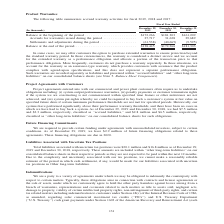According to Sunpower Corporation's financial document, In what situation is warranty accounted as an assurance-type warranty? Customers do not purchase a warranty separately. The document states: "to that performance obligation. More frequently, customers do not purchase a warranty separately. In those situations, we account for the warranty as ..." Also, What does an assurance-type warranty provide? Provides customers with assurance that the product complies with agreed-upon specifications. The document states: "the warranty as an assurance-type warranty, which provides customers with assurance that the product complies with agreed-upon specifications, and thi..." Additionally, Which year has the highest balance at the end of the period? According to the financial document, 2017. The relevant text states: "December 29, 2019 December 30, 2018 December 31, 2017..." Also, can you calculate: What is the percentage change in accruals for warranties issued from 2018 to 2019? To answer this question, I need to perform calculations using the financial data. The calculation is: (27,717 - 31,628)/31,628 , which equals -12.37 (percentage). This is based on the information: "for warranties issued during the period . 27,717 31,628 29,689 Settlements and adjustments during the period . (61,538) (40,665) (9,595) ccruals for warranties issued during the period . 27,717 31,628..." The key data points involved are: 27,717, 31,628. Also, In which years is accrued warranty activities recorded for?  The document contains multiple relevant values: 2019, 2018, 2017. From the document: "December 29, 2019 December 30, 2018 December 31, 2017 (In thousands) December 29, 2019 December 30, 2018 December 31, 2017 (In thousands) December 29,..." Also, can you calculate: What would be the change in balance at the beginning of the period from 2017 to 2018? Based on the calculation: $181,303 - $161,209 , the result is 20094 (in thousands). This is based on the information: "the beginning of the period . $172,266 $181,303 $161,209 Accruals for warranties issued during the period . 27,717 31,628 29,689 Settlements and adjustments alance at the beginning of the period . $17..." The key data points involved are: 161,209, 181,303. 